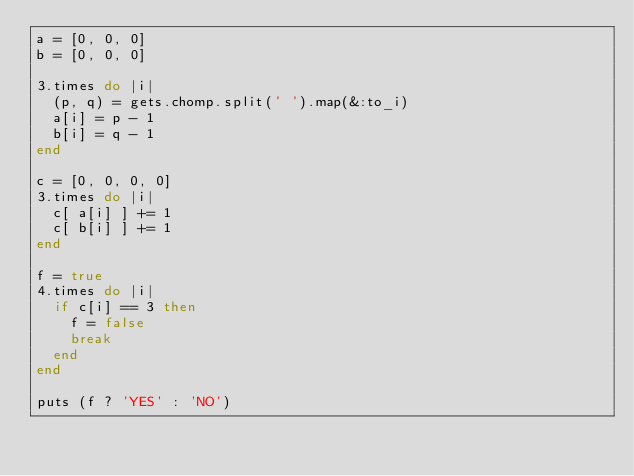Convert code to text. <code><loc_0><loc_0><loc_500><loc_500><_Ruby_>a = [0, 0, 0]
b = [0, 0, 0]

3.times do |i|
  (p, q) = gets.chomp.split(' ').map(&:to_i)
  a[i] = p - 1
  b[i] = q - 1
end

c = [0, 0, 0, 0]
3.times do |i|
  c[ a[i] ] += 1
  c[ b[i] ] += 1
end

f = true
4.times do |i|
  if c[i] == 3 then
    f = false
    break
  end
end
  
puts (f ? 'YES' : 'NO')</code> 